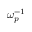<formula> <loc_0><loc_0><loc_500><loc_500>\omega _ { p } ^ { - 1 }</formula> 